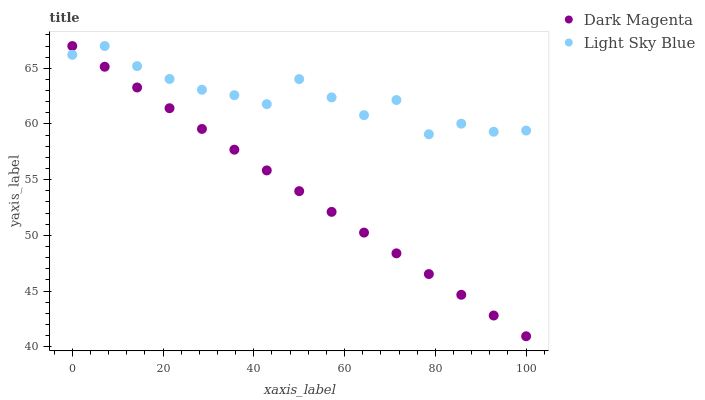Does Dark Magenta have the minimum area under the curve?
Answer yes or no. Yes. Does Light Sky Blue have the maximum area under the curve?
Answer yes or no. Yes. Does Dark Magenta have the maximum area under the curve?
Answer yes or no. No. Is Dark Magenta the smoothest?
Answer yes or no. Yes. Is Light Sky Blue the roughest?
Answer yes or no. Yes. Is Dark Magenta the roughest?
Answer yes or no. No. Does Dark Magenta have the lowest value?
Answer yes or no. Yes. Does Dark Magenta have the highest value?
Answer yes or no. Yes. Does Light Sky Blue intersect Dark Magenta?
Answer yes or no. Yes. Is Light Sky Blue less than Dark Magenta?
Answer yes or no. No. Is Light Sky Blue greater than Dark Magenta?
Answer yes or no. No. 